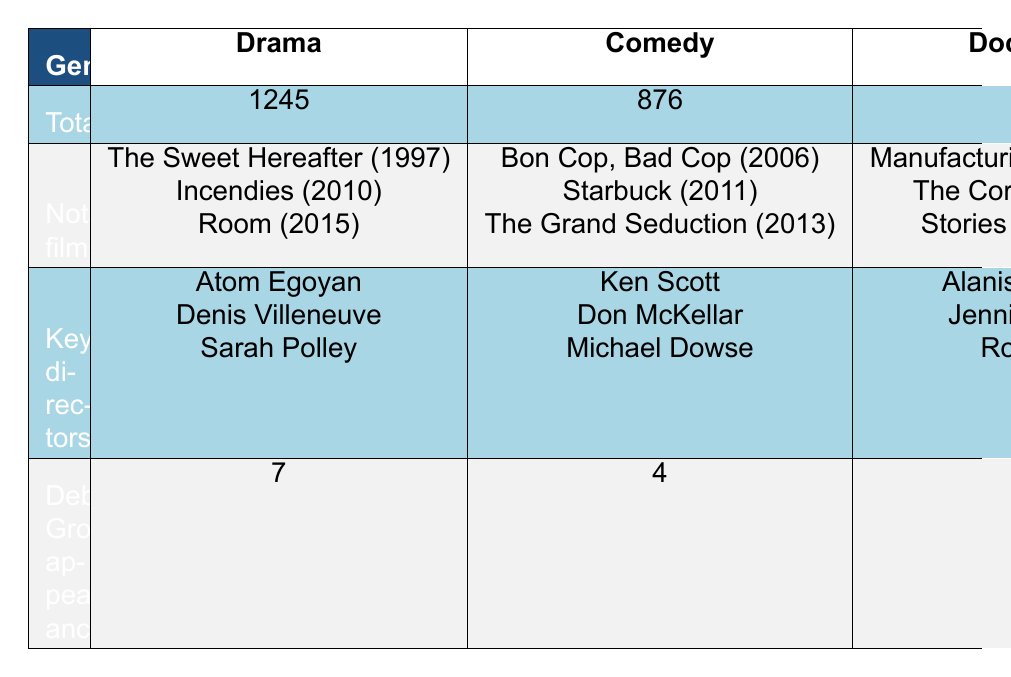What is the total number of Canadian drama films produced from 1990 to 2020? The total number of Canadian drama films is directly provided in the table under the "Total" row for the “Drama” genre. It states 1245.
Answer: 1245 Which genre has the highest number of notable films? By examining the notable films listed under each genre, “Documentary” has three notable films listed, while the others have three as well, but if we consider the total production, Drama has the highest number of total films, producing three notable films too.
Answer: Documentaries and Drama both have three notable films How many Canadian comedy films feature Deborah Grover? The number of Deborah Grover's appearances in the comedy genre is indicated in the table under the "Deborah Grover appearances" row for the “Comedy” genre, which states 4.
Answer: 4 Is the number of Deborah Grover appearances in thriller films greater than in documentaries? The table shows that Deborah Grover appeared in 3 thriller films and only 1 documentary film. Since 3 is greater than 1, the statement is true.
Answer: Yes What is the total number of films produced across all genres from 1990 to 2020? To find the total across all genres, sum the total values for each genre: Drama (1245) + Comedy (876) + Documentary (1532) + Thriller (412) + Romance (298) + Science Fiction (187) = 4150.
Answer: 4150 Which genre has the lowest number of films produced, and what is that number? By comparing the total number of films across all genres listed in the table, “Science Fiction” has the lowest total of 187 films, making it the genre with the least production.
Answer: Science Fiction, 187 What percentage of Deborah Grover's total appearances are in drama films? Deborah Grover has a total of 17 appearances across all genres (7 in Drama, 4 in Comedy, 1 in Documentary, 3 in Thriller, 2 in Romance, and 1 in Science Fiction). To find the percentage in Drama, use: (7/17) * 100 = 41.18%.
Answer: Approximately 41.18% How many more documentary films are there compared to romance films? The total number of documentary films is 1532, while romance films total 298. The difference is calculated by subtracting the total of romance from documentary: 1532 - 298 = 1234.
Answer: 1234 Which two genres have the highest and lowest number of total films produced, respectively? The genre with the highest total is "Documentary" with 1532 films, and the one with the lowest is "Science Fiction" with 187 films.
Answer: Documentary and Science Fiction 